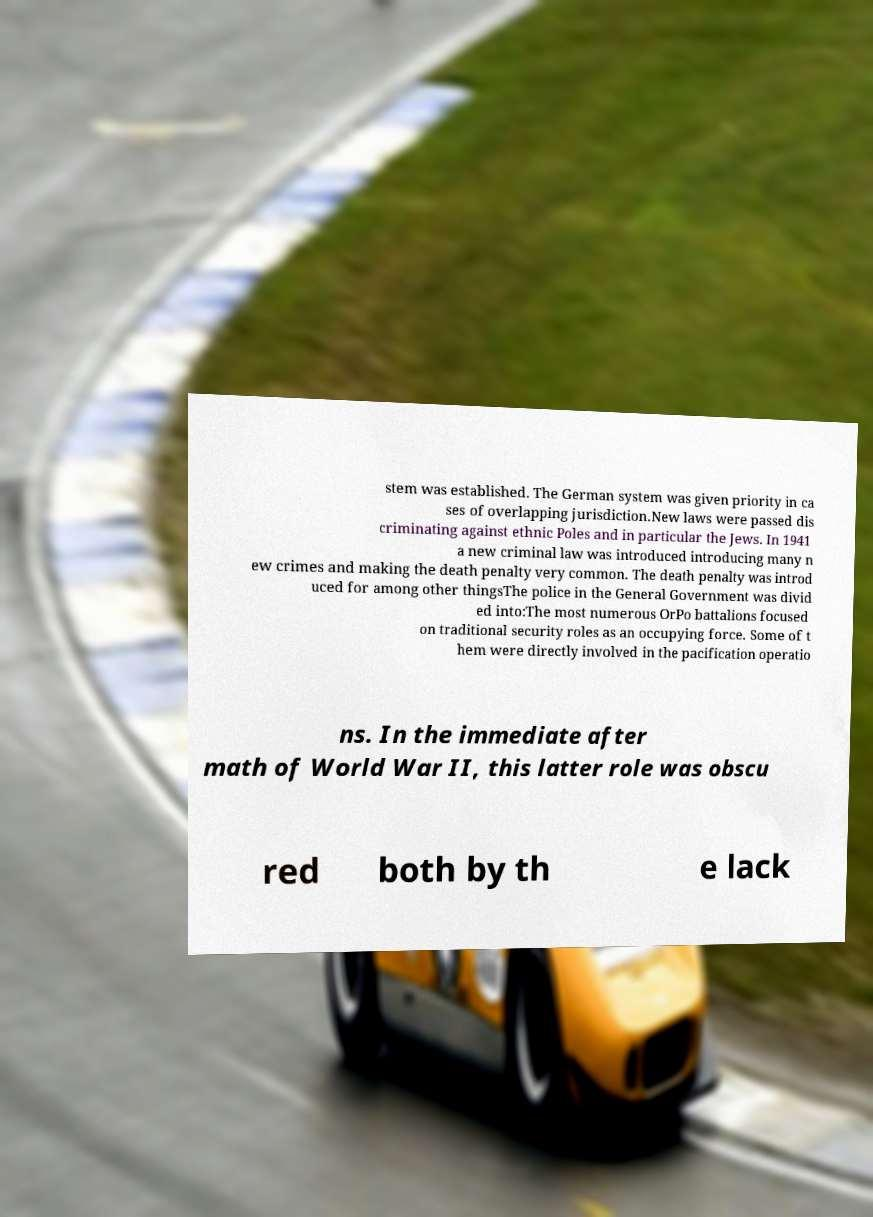Could you extract and type out the text from this image? stem was established. The German system was given priority in ca ses of overlapping jurisdiction.New laws were passed dis criminating against ethnic Poles and in particular the Jews. In 1941 a new criminal law was introduced introducing many n ew crimes and making the death penalty very common. The death penalty was introd uced for among other thingsThe police in the General Government was divid ed into:The most numerous OrPo battalions focused on traditional security roles as an occupying force. Some of t hem were directly involved in the pacification operatio ns. In the immediate after math of World War II, this latter role was obscu red both by th e lack 